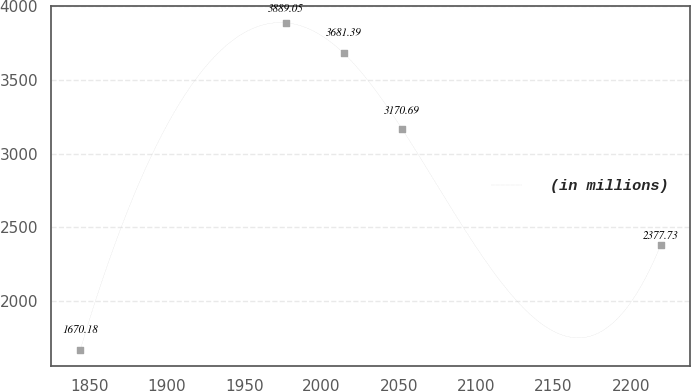Convert chart. <chart><loc_0><loc_0><loc_500><loc_500><line_chart><ecel><fcel>(in millions)<nl><fcel>1843.92<fcel>1670.18<nl><fcel>1976.89<fcel>3889.05<nl><fcel>2014.43<fcel>3681.39<nl><fcel>2051.97<fcel>3170.69<nl><fcel>2219.31<fcel>2377.73<nl></chart> 